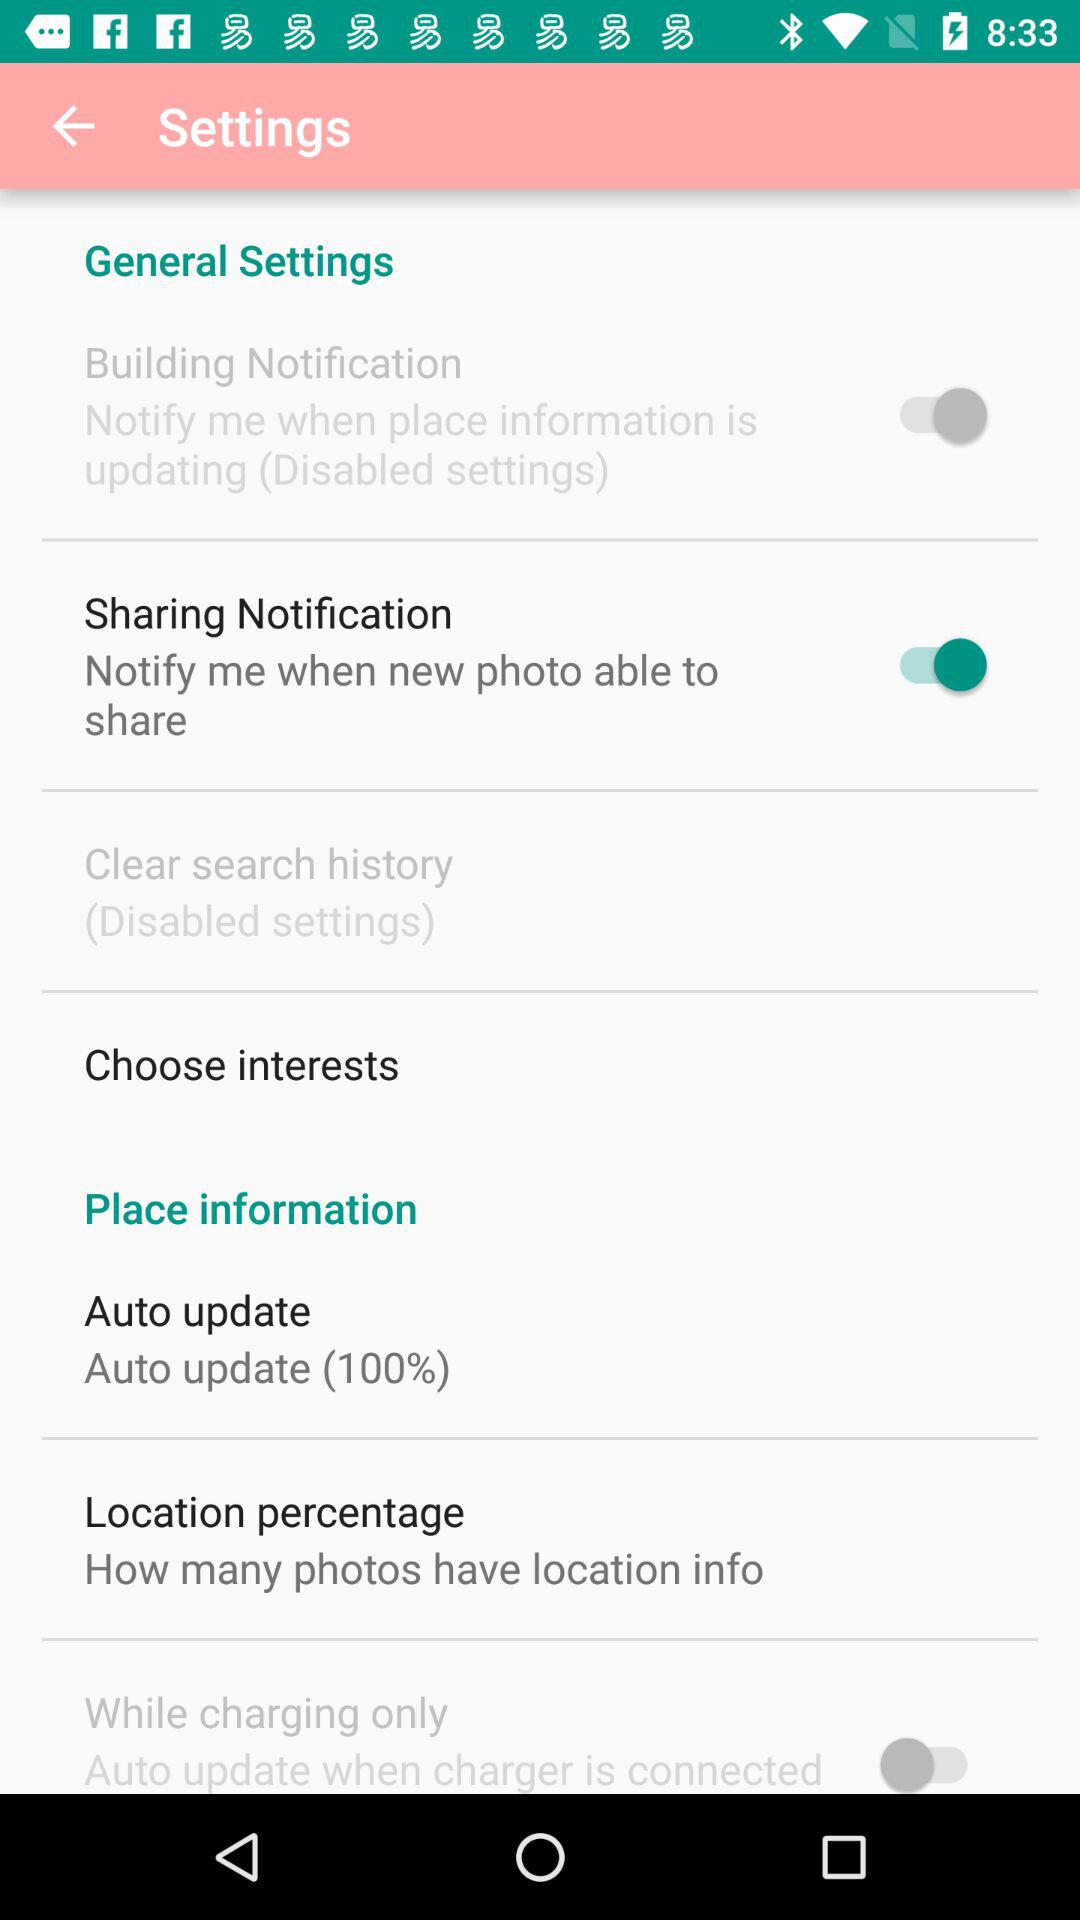When was the last auto-update?
When the provided information is insufficient, respond with <no answer>. <no answer> 